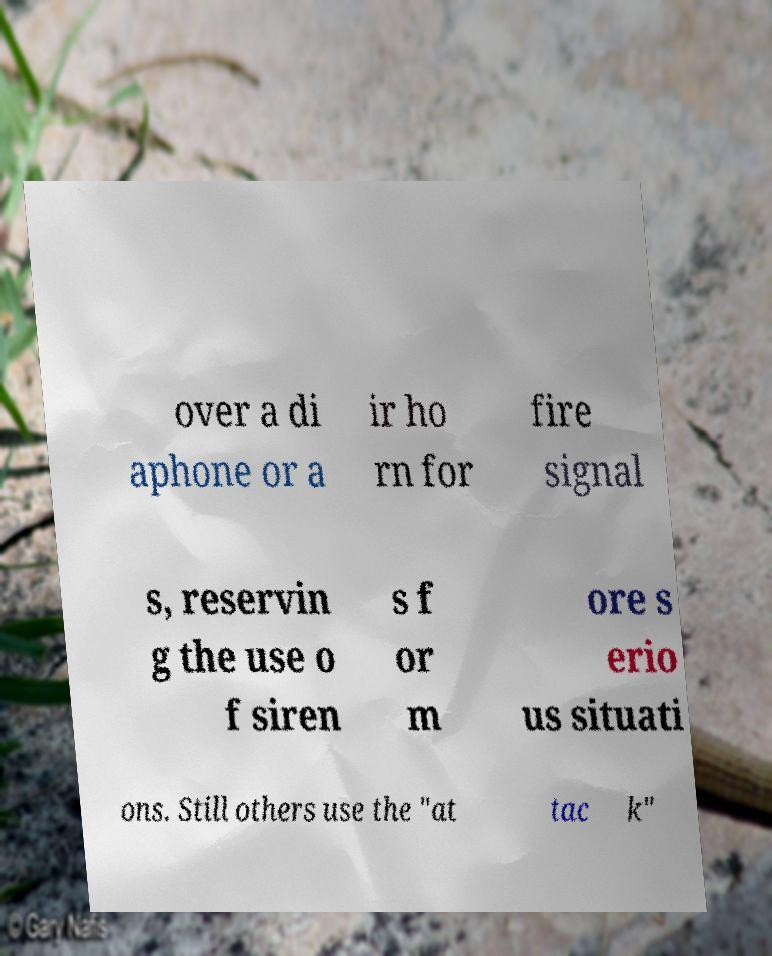I need the written content from this picture converted into text. Can you do that? over a di aphone or a ir ho rn for fire signal s, reservin g the use o f siren s f or m ore s erio us situati ons. Still others use the "at tac k" 